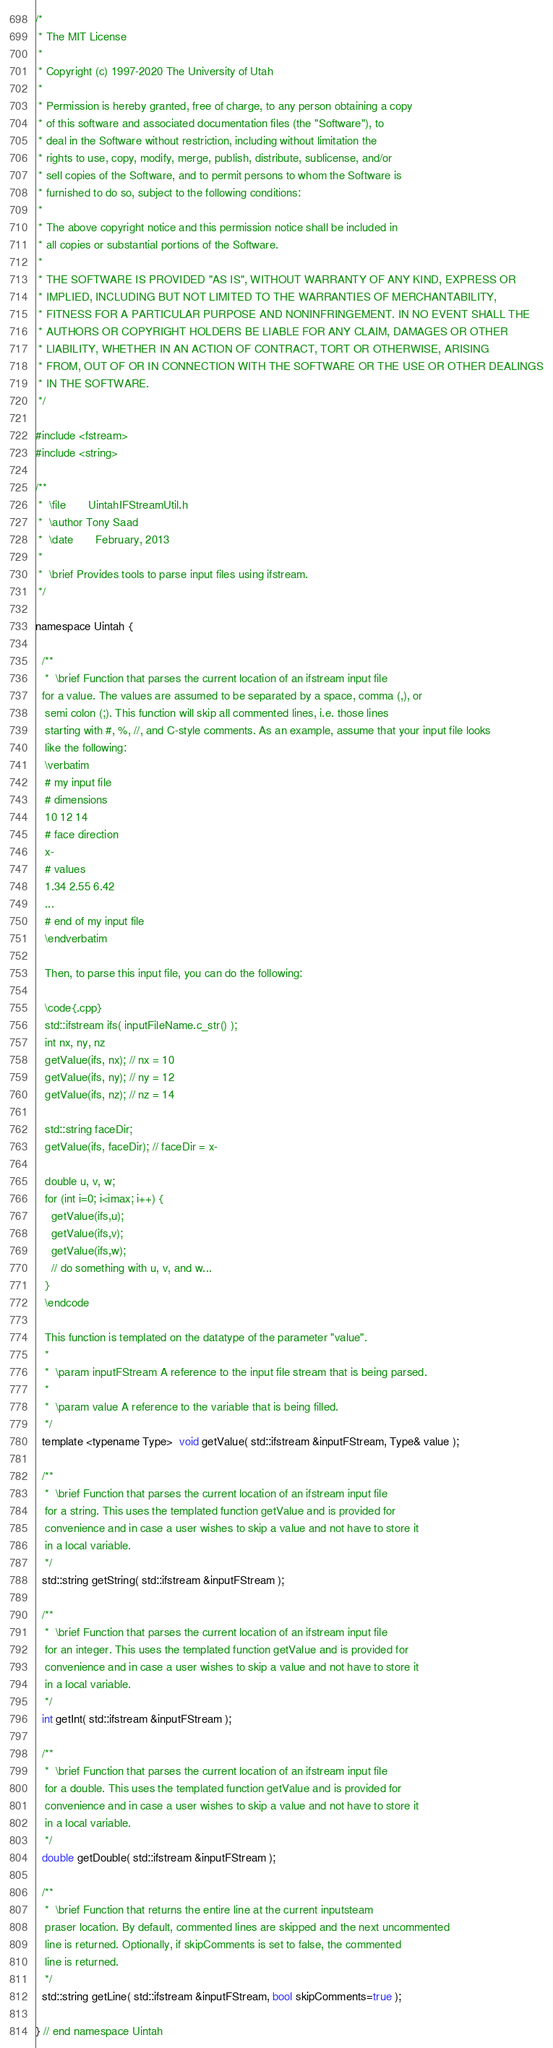Convert code to text. <code><loc_0><loc_0><loc_500><loc_500><_C_>/*
 * The MIT License
 *
 * Copyright (c) 1997-2020 The University of Utah
 *
 * Permission is hereby granted, free of charge, to any person obtaining a copy
 * of this software and associated documentation files (the "Software"), to
 * deal in the Software without restriction, including without limitation the
 * rights to use, copy, modify, merge, publish, distribute, sublicense, and/or
 * sell copies of the Software, and to permit persons to whom the Software is
 * furnished to do so, subject to the following conditions:
 *
 * The above copyright notice and this permission notice shall be included in
 * all copies or substantial portions of the Software.
 *
 * THE SOFTWARE IS PROVIDED "AS IS", WITHOUT WARRANTY OF ANY KIND, EXPRESS OR
 * IMPLIED, INCLUDING BUT NOT LIMITED TO THE WARRANTIES OF MERCHANTABILITY,
 * FITNESS FOR A PARTICULAR PURPOSE AND NONINFRINGEMENT. IN NO EVENT SHALL THE
 * AUTHORS OR COPYRIGHT HOLDERS BE LIABLE FOR ANY CLAIM, DAMAGES OR OTHER
 * LIABILITY, WHETHER IN AN ACTION OF CONTRACT, TORT OR OTHERWISE, ARISING
 * FROM, OUT OF OR IN CONNECTION WITH THE SOFTWARE OR THE USE OR OTHER DEALINGS
 * IN THE SOFTWARE.
 */

#include <fstream>
#include <string>

/**
 *  \file       UintahIFStreamUtil.h
 *  \author Tony Saad
 *  \date       February, 2013
 *
 *  \brief Provides tools to parse input files using ifstream.
 */

namespace Uintah {
  
  /**
   *  \brief Function that parses the current location of an ifstream input file 
  for a value. The values are assumed to be separated by a space, comma (,), or
   semi colon (;). This function will skip all commented lines, i.e. those lines
   starting with #, %, //, and C-style comments. As an example, assume that your input file looks
   like the following:
   \verbatim
   # my input file
   # dimensions
   10 12 14
   # face direction
   x-
   # values
   1.34 2.55 6.42
   ...
   # end of my input file
   \endverbatim
   
   Then, to parse this input file, you can do the following:
   
   \code{.cpp}
   std::ifstream ifs( inputFileName.c_str() );
   int nx, ny, nz
   getValue(ifs, nx); // nx = 10
   getValue(ifs, ny); // ny = 12
   getValue(ifs, nz); // nz = 14
   
   std::string faceDir;
   getValue(ifs, faceDir); // faceDir = x-
   
   double u, v, w;
   for (int i=0; i<imax; i++) {
     getValue(ifs,u);
     getValue(ifs,v);
     getValue(ifs,w);
     // do something with u, v, and w...
   }
   \endcode
   
   This function is templated on the datatype of the parameter "value".
   *
   *  \param inputFStream A reference to the input file stream that is being parsed.
   *
   *  \param value A reference to the variable that is being filled.
   */
  template <typename Type>  void getValue( std::ifstream &inputFStream, Type& value );
  
  /**
   *  \brief Function that parses the current location of an ifstream input file
   for a string. This uses the templated function getValue and is provided for
   convenience and in case a user wishes to skip a value and not have to store it
   in a local variable.
   */
  std::string getString( std::ifstream &inputFStream );

  /**
   *  \brief Function that parses the current location of an ifstream input file
   for an integer. This uses the templated function getValue and is provided for
   convenience and in case a user wishes to skip a value and not have to store it
   in a local variable.
   */
  int getInt( std::ifstream &inputFStream );
  
  /**
   *  \brief Function that parses the current location of an ifstream input file
   for a double. This uses the templated function getValue and is provided for
   convenience and in case a user wishes to skip a value and not have to store it
   in a local variable.
   */
  double getDouble( std::ifstream &inputFStream );
  
  /**
   *  \brief Function that returns the entire line at the current inputsteam
   praser location. By default, commented lines are skipped and the next uncommented
   line is returned. Optionally, if skipComments is set to false, the commented
   line is returned.
   */
  std::string getLine( std::ifstream &inputFStream, bool skipComments=true );
  
} // end namespace Uintah
</code> 